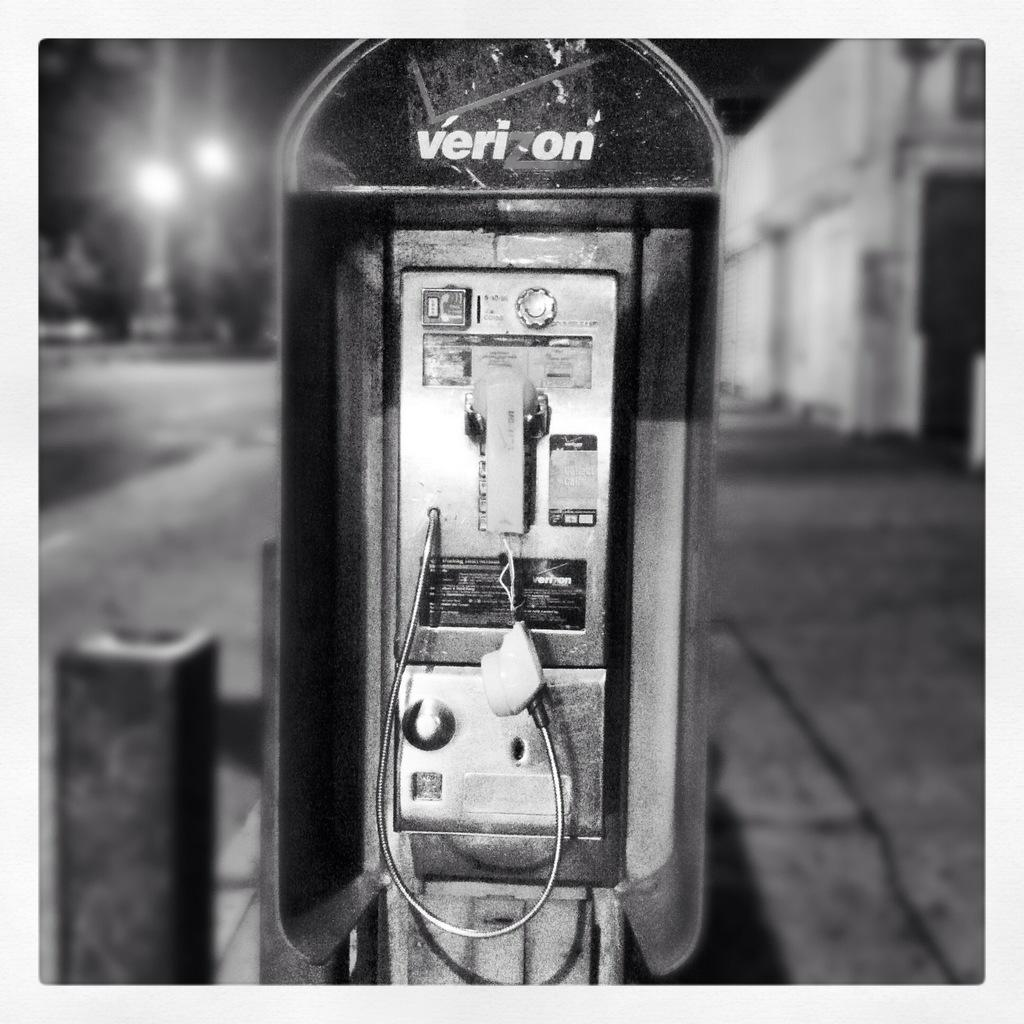<image>
Write a terse but informative summary of the picture. a verizon phone that is broken and in black and white 